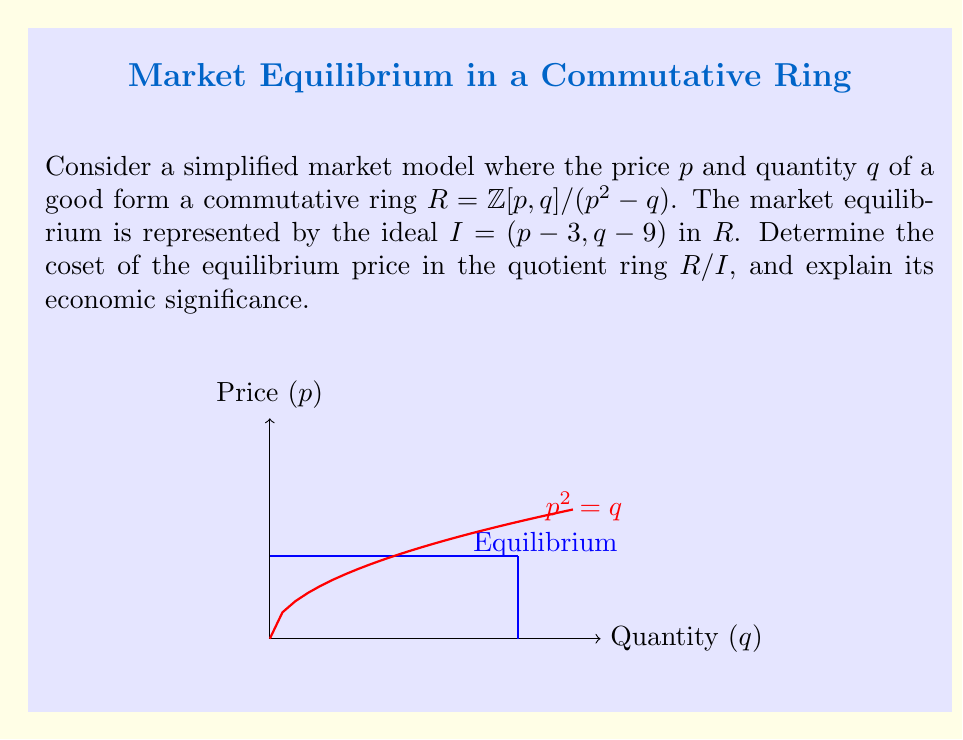Show me your answer to this math problem. Let's approach this step-by-step:

1) The ring $R = \mathbb{Z}[p,q]/(p^2 - q)$ represents our market model. This means that in this ring, the relation $p^2 = q$ always holds.

2) The ideal $I = (p - 3, q - 9)$ represents the market equilibrium. This means that at equilibrium, $p = 3$ and $q = 9$.

3) To find the coset of the equilibrium price in $R/I$, we need to consider $p + I$ in $R/I$.

4) In $R/I$, we have:
   $p \equiv 3 \pmod{I}$
   $q \equiv 9 \pmod{I}$

5) Therefore, the coset of the equilibrium price is $3 + I$ in $R/I$.

6) Economic significance: 
   - The coset $3 + I$ represents all prices that are equivalent to the equilibrium price in this market model.
   - Any price in this coset will result in the same market behavior as the equilibrium price.
   - The fact that this is a coset in a quotient ring shows that the equilibrium is stable under the operations defined in our market model (addition and multiplication of prices and quantities).

7) We can verify that this makes sense in our original ring $R$:
   At equilibrium, $p = 3$ and $q = 9$
   Indeed, $3^2 = 9$, satisfying the condition $p^2 = q$ in $R$.
Answer: $3 + I$ in $R/I$ 